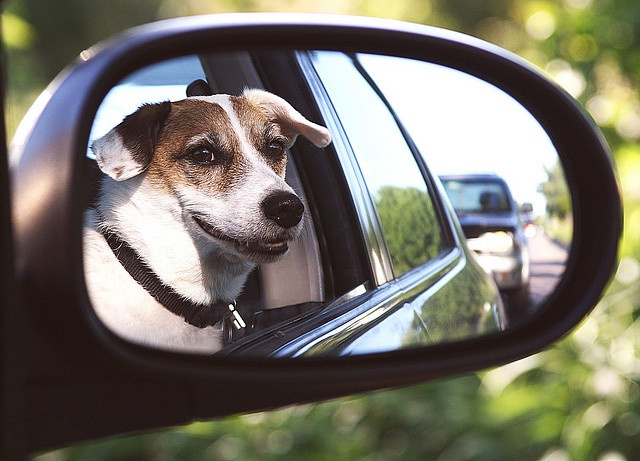Describe the objects in this image and their specific colors. I can see car in black, white, gray, and olive tones, dog in black, white, gray, and darkgray tones, and car in black, white, gray, and darkgray tones in this image. 